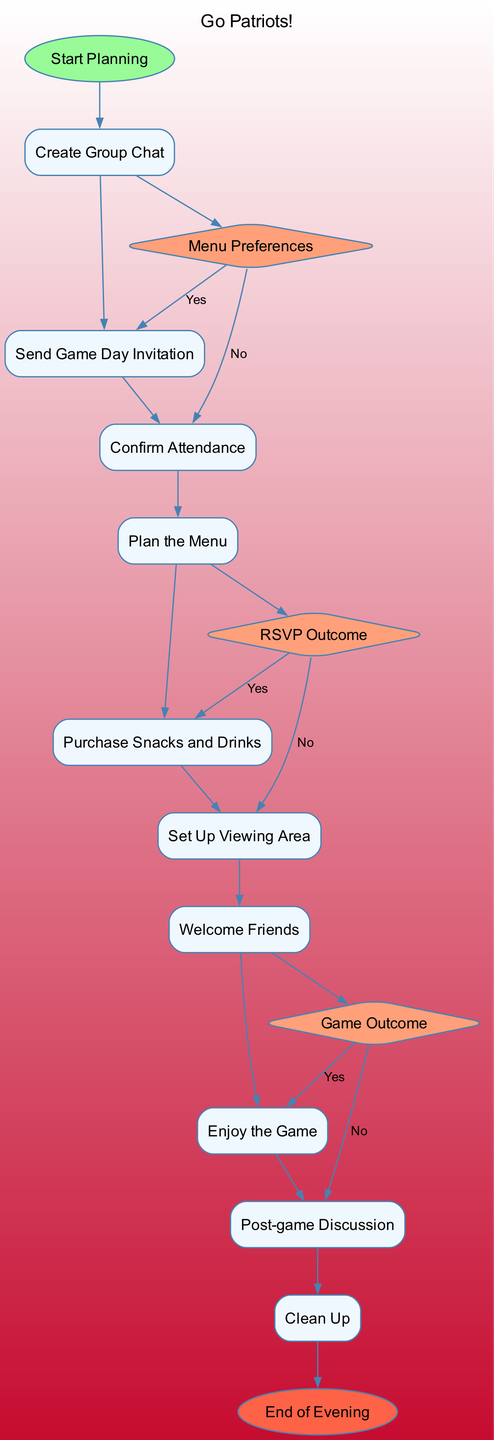What is the starting point of the activity diagram? The starting point is labeled "Start Planning", which signifies the beginning of the process for coordinating the game day viewing with friends.
Answer: Start Planning How many activities are listed in the diagram? There are ten activities outlined in the diagram, detailing the steps for organizing the game day.
Answer: 10 What is the final node in the diagram? The last node is labeled "End of Evening", indicating the conclusion of the game day activities after clean-up.
Answer: End of Evening What decision point follows "Confirm Attendance"? The decision point that occurs after confirming attendance is "RSVP Outcome", which helps to determine the final attendee list.
Answer: RSVP Outcome What snack-related decision is made during the planning process? The decision point specifically related to snacks is "Menu Preferences", where choices are made based on friends' snack preferences.
Answer: Menu Preferences Describe the flow from "Set Up Viewing Area" to "Post-game Discussion". From "Set Up Viewing Area", the flow leads to "Welcome Friends", then to "Enjoy the Game", and finally to "Post-game Discussion" after the game concludes.
Answer: Welcome Friends, Enjoy the Game, Post-game Discussion How does the diagram reflect the outcome of the game? The diagram includes a decision point named "Game Outcome", which describes how the group reacts based on whether the Patriots won or lost, illustrating the impact of the game’s unpredictability.
Answer: Game Outcome What shape is used to represent decision points in the diagram? Decision points are represented by a diamond shape, which is a common convention in activity diagrams to indicate a branching decision or choice.
Answer: Diamond What color is used for the end node? The end node is colored red (#FF6347), which visually distinguishes it from other nodes and indicates the conclusion of the activity.
Answer: Red 